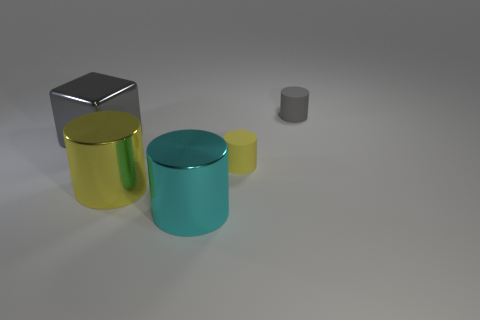There is a gray thing in front of the small object to the right of the tiny yellow cylinder; what is its shape? cube 